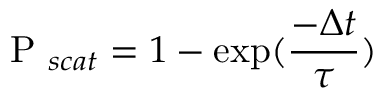<formula> <loc_0><loc_0><loc_500><loc_500>P _ { s c a t } = 1 - \exp ( \frac { - \Delta t } { \tau } )</formula> 